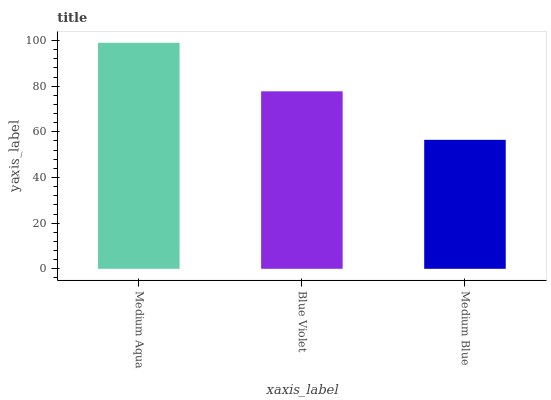Is Medium Blue the minimum?
Answer yes or no. Yes. Is Medium Aqua the maximum?
Answer yes or no. Yes. Is Blue Violet the minimum?
Answer yes or no. No. Is Blue Violet the maximum?
Answer yes or no. No. Is Medium Aqua greater than Blue Violet?
Answer yes or no. Yes. Is Blue Violet less than Medium Aqua?
Answer yes or no. Yes. Is Blue Violet greater than Medium Aqua?
Answer yes or no. No. Is Medium Aqua less than Blue Violet?
Answer yes or no. No. Is Blue Violet the high median?
Answer yes or no. Yes. Is Blue Violet the low median?
Answer yes or no. Yes. Is Medium Blue the high median?
Answer yes or no. No. Is Medium Blue the low median?
Answer yes or no. No. 